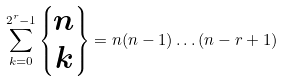Convert formula to latex. <formula><loc_0><loc_0><loc_500><loc_500>\sum ^ { 2 ^ { r } - 1 } _ { k = 0 } \left \{ \begin{matrix} n \\ k \end{matrix} \right \} = n ( n - 1 ) \hdots ( n - r + 1 )</formula> 